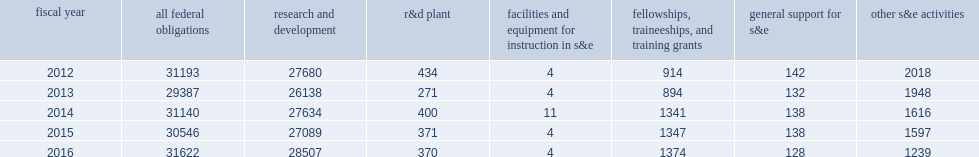In fy 2016, how many million dollars did federal agencies obligate to institutions of higher education in support of science and engineering (s&e)? 31622.0. In fy 2015, how many million dollars did federal agencies obligate to institutions of higher education in support of science and engineering (s&e)? 30546.0. 